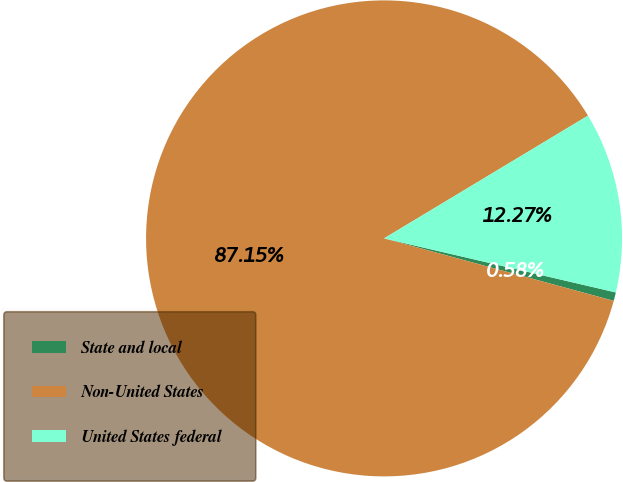<chart> <loc_0><loc_0><loc_500><loc_500><pie_chart><fcel>State and local<fcel>Non-United States<fcel>United States federal<nl><fcel>0.58%<fcel>87.15%<fcel>12.27%<nl></chart> 